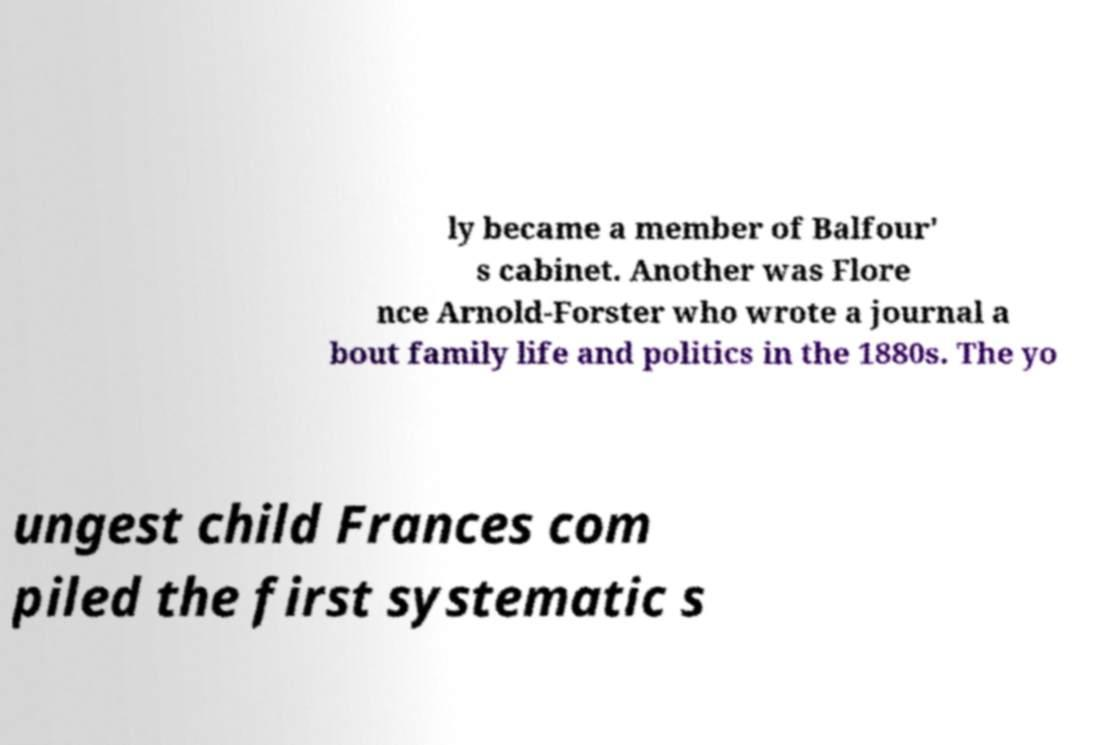Can you read and provide the text displayed in the image?This photo seems to have some interesting text. Can you extract and type it out for me? ly became a member of Balfour' s cabinet. Another was Flore nce Arnold-Forster who wrote a journal a bout family life and politics in the 1880s. The yo ungest child Frances com piled the first systematic s 